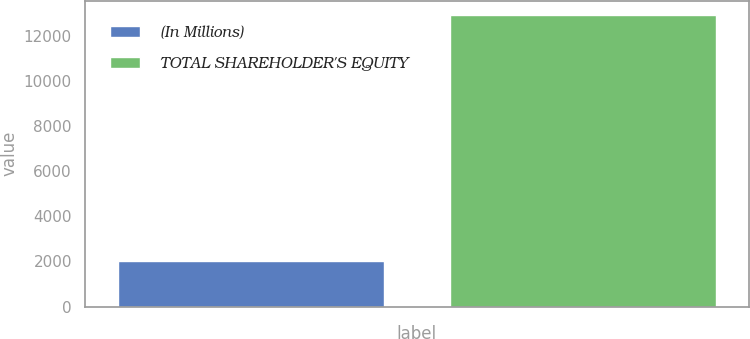Convert chart. <chart><loc_0><loc_0><loc_500><loc_500><bar_chart><fcel>(In Millions)<fcel>TOTAL SHAREHOLDER'S EQUITY<nl><fcel>2018<fcel>12915<nl></chart> 